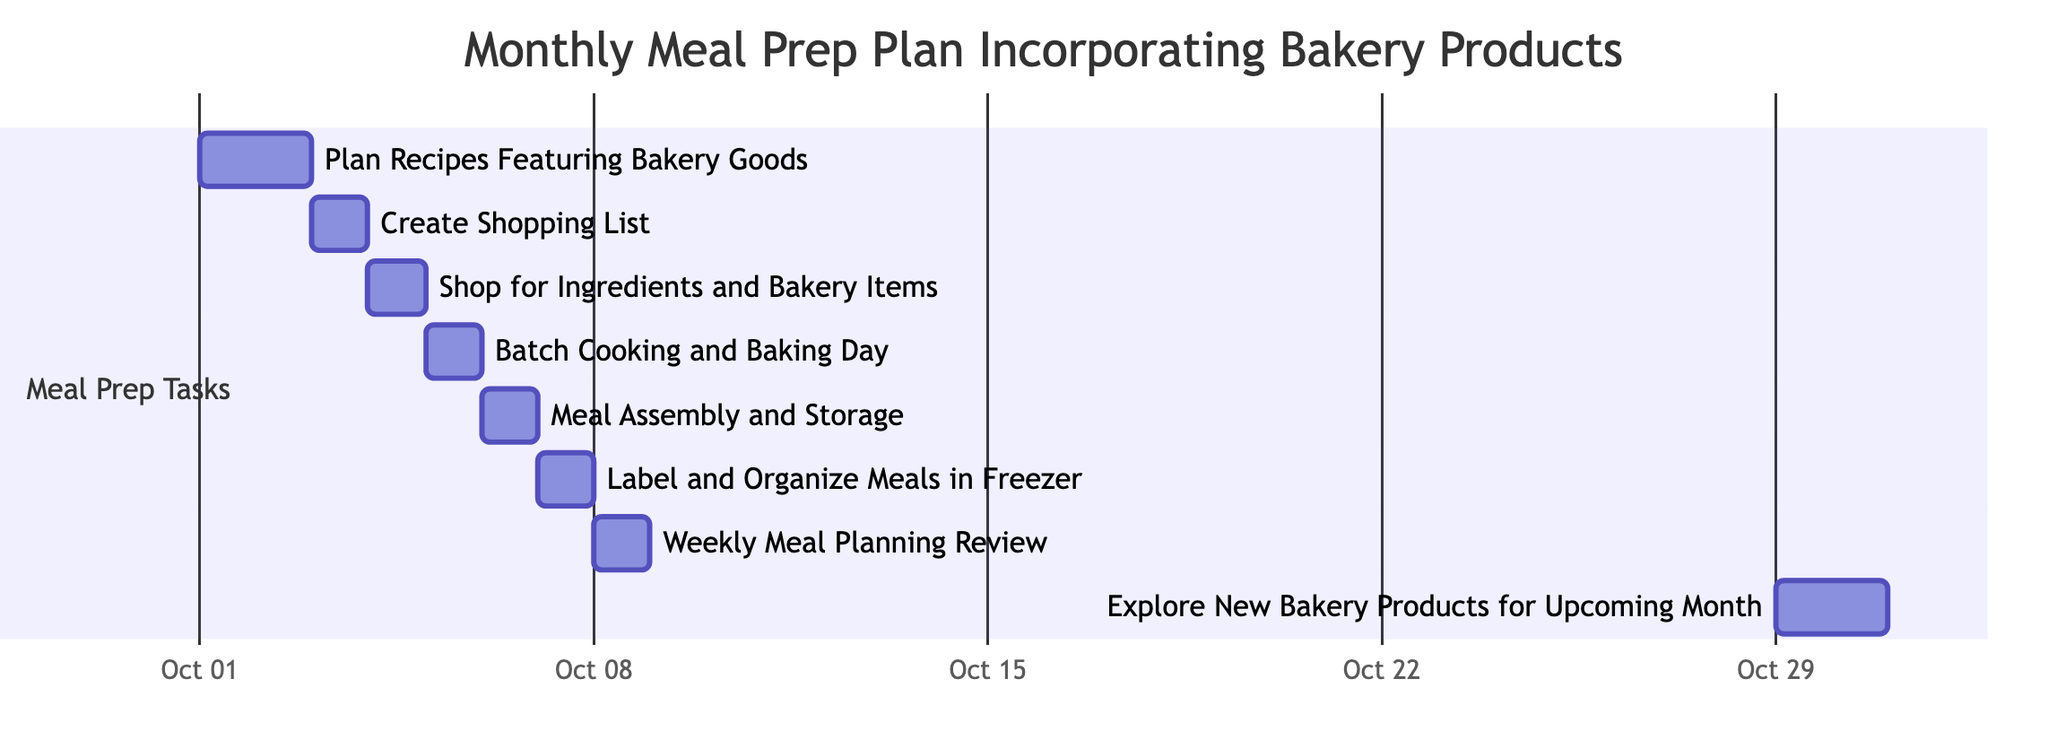What is the duration of the "Plan Recipes Featuring Bakery Goods" task? The "Plan Recipes Featuring Bakery Goods" task starts on October 1, 2023, and ends on October 2, 2023. Therefore, the duration is from the start date to the end date, which is 2 days.
Answer: 2 days How many tasks are completed in the first week of October? The tasks scheduled from October 1 to October 7 are "Plan Recipes Featuring Bakery Goods," "Create Shopping List," "Shop for Ingredients and Bakery Items," "Batch Cooking and Baking Day," "Meal Assembly and Storage," and "Label and Organize Meals in Freezer." There are 6 tasks completed in this period.
Answer: 6 What is the last task listed in the meal prep plan? The last task listed in the meal prep plan is "Explore New Bakery Products for Upcoming Month," which occurs from October 29 to October 30, 2023.
Answer: Explore New Bakery Products for Upcoming Month Which task occurs immediately after "Meal Assembly and Storage"? The task that occurs immediately after "Meal Assembly and Storage," which ends on October 6, is "Label and Organize Meals in Freezer," which starts on October 7.
Answer: Label and Organize Meals in Freezer How many total days are allocated for the entire meal prep plan? The meal prep plan has multiple tasks with varying days. Summing the task durations gives: 2 (Plan Recipes) + 1 (Shopping List) + 1 (Shopping) + 1 (Cooking) + 1 (Assembly) + 1 (Labeling) + 1 (Review) + 2 (Exploring New Items) = 10 days. Thus, the total duration is 10 days.
Answer: 10 days What starting date marks the beginning of the final task? The final task "Explore New Bakery Products for Upcoming Month" starts on October 29, 2023.
Answer: October 29 Which task has the same duration as "Create Shopping List"? Both "Create Shopping List" and "Shop for Ingredients and Bakery Items" have a duration of 1 day each; therefore, these two tasks share the same duration.
Answer: Shop for Ingredients and Bakery Items 